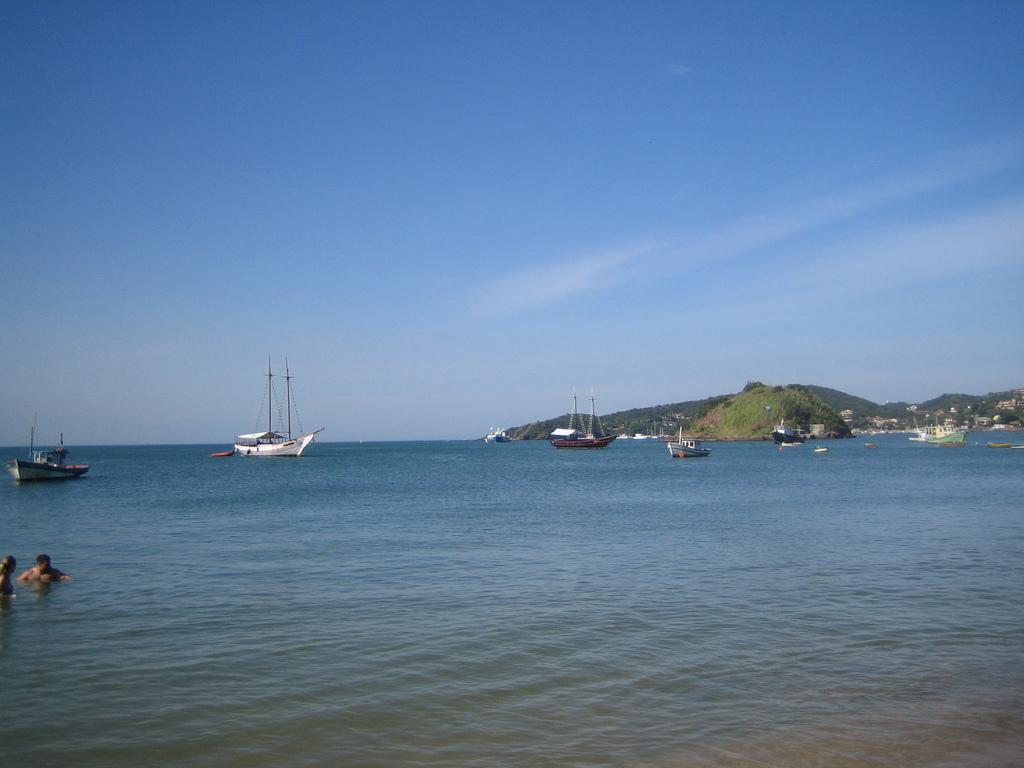In one or two sentences, can you explain what this image depicts? It is a sea and there are many ships and boats sailing on the sea, on the left side two people are swimming in the water and there are few mountains in the background. 